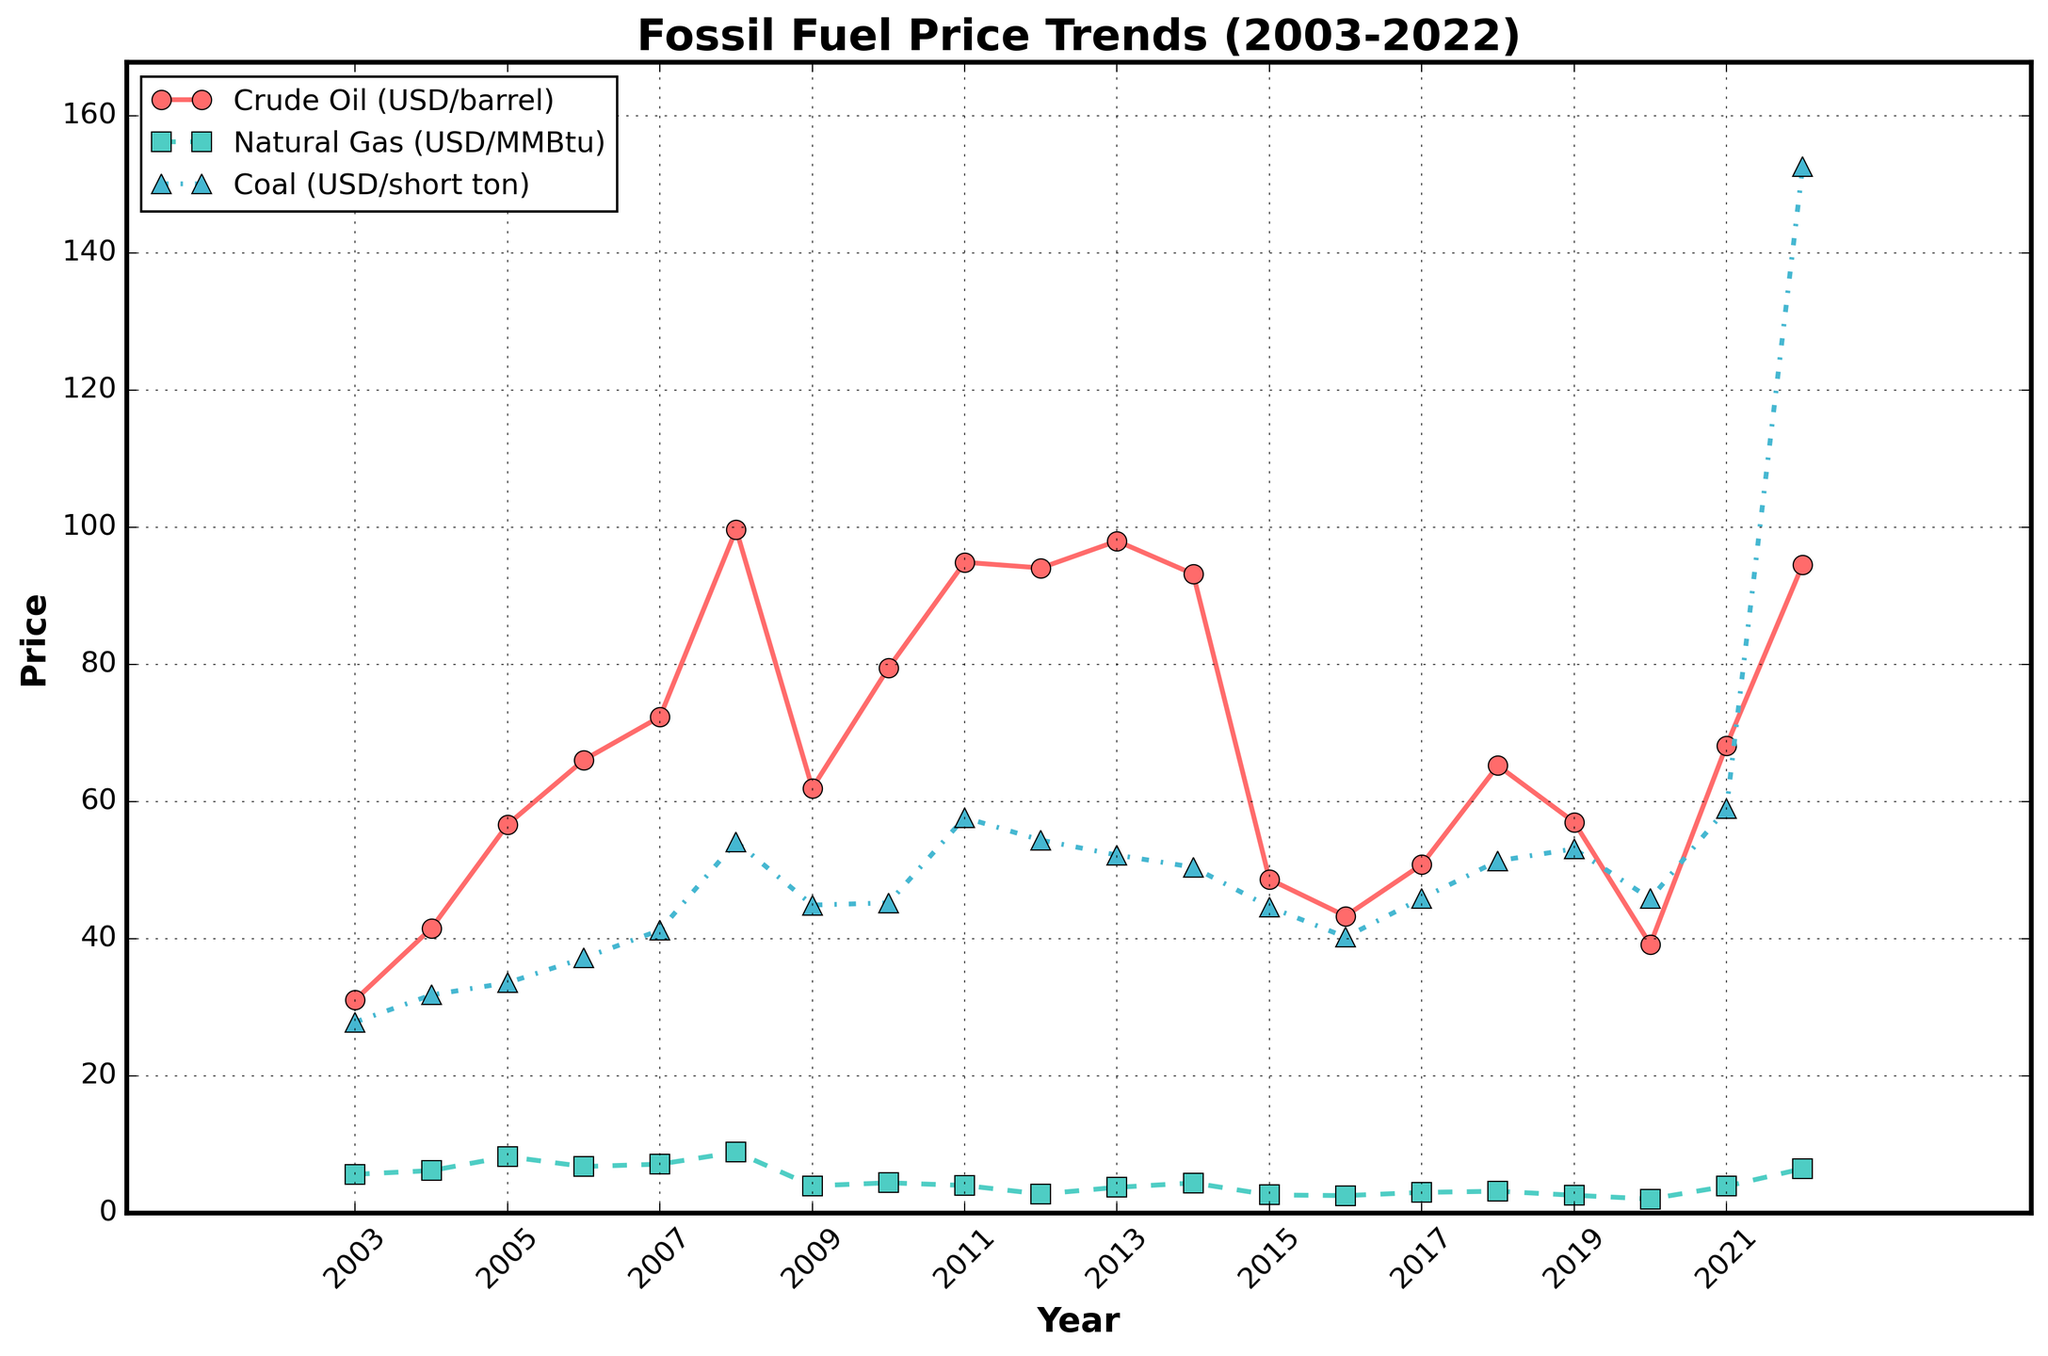What trend is evident for crude oil prices from 2003 to 2022? The crude oil prices generally show an upward trend until 2008, then have some fluctuations, peaking in 2008 and showing a significant drop in 2015, followed by slight fluctuations until a notable rise in 2021 and 2022.
Answer: Upward until 2008, fluctuations, then rise in 2021/2022 Which year had the highest price for natural gas? By comparing the peaks on the green dashed line, 2008 and 2022 are notable, with 2022 being the highest.
Answer: 2022 What was the price difference between coal and natural gas in 2022? In 2022, the coal price is approximately 152.56 USD/short ton, and the natural gas price is about 6.45 USD/MMBtu. The difference is found by subtracting the natural gas price from the coal price: 152.56 - 6.45.
Answer: 146.11 What is the general trend of coal prices, and how does it differ from crude oil prices over the same period? Coal prices show a generally more stable increase compared to the sharp peaks and drops seen in crude oil prices. The coal peak in 2022 is significantly higher than any previous years.
Answer: Stable increase, sharp rise in 2022 During which year(s) did crude oil prices exceed 90 USD/barrel? By looking at where the red line crosses the 90 USD/barrel mark, the years are approximately 2008, 2011, 2012, 2013, 2014, and 2022.
Answer: 2008, 2011-2014, 2022 How did the natural gas price change from 2008 to 2009? The green dashed line shows a noticeable drop from 8.86 in 2008 to 3.95 in 2009.
Answer: Decreased How does the coal price in 2015 compare to that in 2020? The blue dotted line in 2015 shows a price of 44.63, whereas in 2020, it shows a price of 45.82. By comparing these values, coal prices slightly increased from 2015 to 2020.
Answer: Slightly increased What can be inferred about the stability of natural gas prices compared to crude oil and coal prices in the given period? Natural gas prices (green dashed line) are generally more volatile with bigger fluctuations compared to coal prices (blue dotted line), and have fewer dramatic peaks compared to crude oil prices (red solid line).
Answer: More volatile 